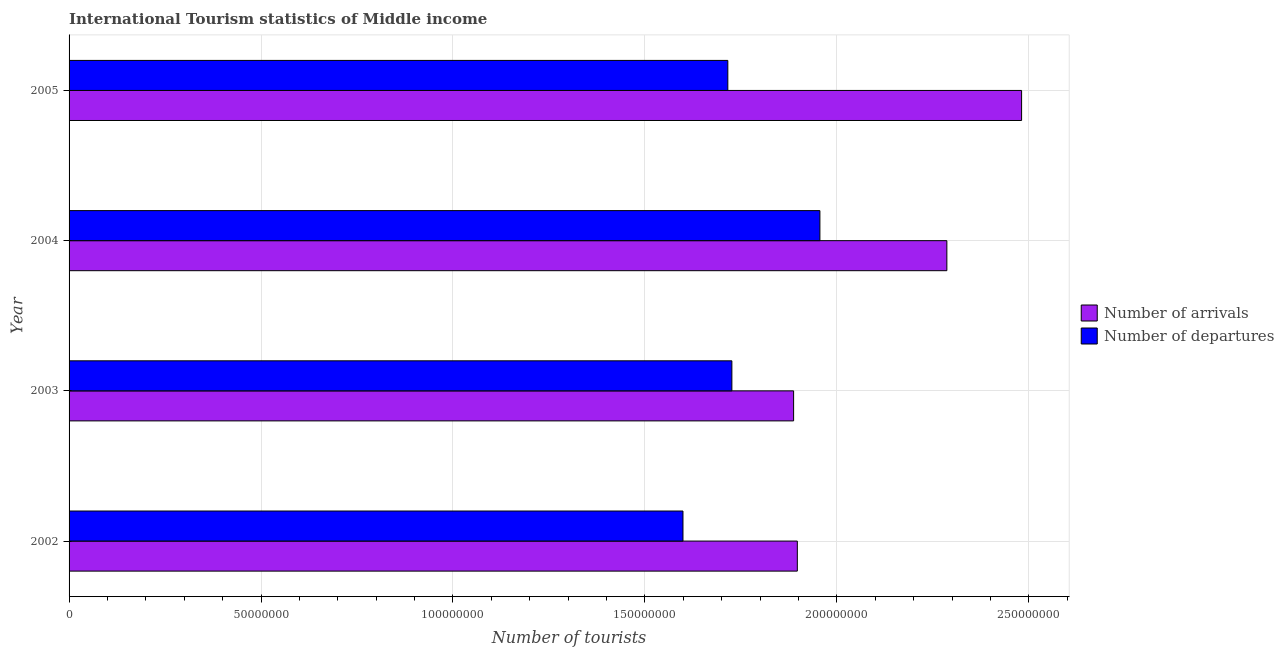How many groups of bars are there?
Keep it short and to the point. 4. Are the number of bars on each tick of the Y-axis equal?
Make the answer very short. Yes. How many bars are there on the 2nd tick from the top?
Keep it short and to the point. 2. What is the label of the 4th group of bars from the top?
Your answer should be compact. 2002. What is the number of tourist arrivals in 2003?
Provide a short and direct response. 1.89e+08. Across all years, what is the maximum number of tourist departures?
Provide a succinct answer. 1.96e+08. Across all years, what is the minimum number of tourist arrivals?
Make the answer very short. 1.89e+08. In which year was the number of tourist departures minimum?
Your answer should be compact. 2002. What is the total number of tourist arrivals in the graph?
Your answer should be compact. 8.55e+08. What is the difference between the number of tourist departures in 2002 and that in 2003?
Offer a very short reply. -1.27e+07. What is the difference between the number of tourist arrivals in 2002 and the number of tourist departures in 2003?
Offer a terse response. 1.70e+07. What is the average number of tourist arrivals per year?
Offer a terse response. 2.14e+08. In the year 2003, what is the difference between the number of tourist departures and number of tourist arrivals?
Offer a terse response. -1.61e+07. What is the ratio of the number of tourist departures in 2002 to that in 2004?
Provide a short and direct response. 0.82. Is the difference between the number of tourist departures in 2002 and 2005 greater than the difference between the number of tourist arrivals in 2002 and 2005?
Ensure brevity in your answer.  Yes. What is the difference between the highest and the second highest number of tourist arrivals?
Your answer should be very brief. 1.95e+07. What is the difference between the highest and the lowest number of tourist arrivals?
Make the answer very short. 5.94e+07. In how many years, is the number of tourist departures greater than the average number of tourist departures taken over all years?
Offer a very short reply. 1. What does the 2nd bar from the top in 2002 represents?
Keep it short and to the point. Number of arrivals. What does the 1st bar from the bottom in 2003 represents?
Make the answer very short. Number of arrivals. How many years are there in the graph?
Give a very brief answer. 4. What is the difference between two consecutive major ticks on the X-axis?
Keep it short and to the point. 5.00e+07. Are the values on the major ticks of X-axis written in scientific E-notation?
Offer a very short reply. No. Does the graph contain any zero values?
Offer a terse response. No. Does the graph contain grids?
Your response must be concise. Yes. How are the legend labels stacked?
Your response must be concise. Vertical. What is the title of the graph?
Provide a succinct answer. International Tourism statistics of Middle income. Does "Frequency of shipment arrival" appear as one of the legend labels in the graph?
Offer a terse response. No. What is the label or title of the X-axis?
Your response must be concise. Number of tourists. What is the label or title of the Y-axis?
Offer a terse response. Year. What is the Number of tourists in Number of arrivals in 2002?
Make the answer very short. 1.90e+08. What is the Number of tourists in Number of departures in 2002?
Give a very brief answer. 1.60e+08. What is the Number of tourists in Number of arrivals in 2003?
Provide a short and direct response. 1.89e+08. What is the Number of tourists in Number of departures in 2003?
Provide a succinct answer. 1.73e+08. What is the Number of tourists of Number of arrivals in 2004?
Your answer should be compact. 2.29e+08. What is the Number of tourists in Number of departures in 2004?
Your answer should be very brief. 1.96e+08. What is the Number of tourists in Number of arrivals in 2005?
Provide a succinct answer. 2.48e+08. What is the Number of tourists in Number of departures in 2005?
Keep it short and to the point. 1.72e+08. Across all years, what is the maximum Number of tourists in Number of arrivals?
Your answer should be compact. 2.48e+08. Across all years, what is the maximum Number of tourists of Number of departures?
Keep it short and to the point. 1.96e+08. Across all years, what is the minimum Number of tourists in Number of arrivals?
Ensure brevity in your answer.  1.89e+08. Across all years, what is the minimum Number of tourists of Number of departures?
Your answer should be compact. 1.60e+08. What is the total Number of tourists in Number of arrivals in the graph?
Provide a short and direct response. 8.55e+08. What is the total Number of tourists in Number of departures in the graph?
Offer a terse response. 7.00e+08. What is the difference between the Number of tourists in Number of arrivals in 2002 and that in 2003?
Give a very brief answer. 9.66e+05. What is the difference between the Number of tourists of Number of departures in 2002 and that in 2003?
Offer a terse response. -1.27e+07. What is the difference between the Number of tourists of Number of arrivals in 2002 and that in 2004?
Your response must be concise. -3.90e+07. What is the difference between the Number of tourists in Number of departures in 2002 and that in 2004?
Offer a terse response. -3.57e+07. What is the difference between the Number of tourists in Number of arrivals in 2002 and that in 2005?
Make the answer very short. -5.84e+07. What is the difference between the Number of tourists in Number of departures in 2002 and that in 2005?
Provide a succinct answer. -1.17e+07. What is the difference between the Number of tourists of Number of arrivals in 2003 and that in 2004?
Your answer should be very brief. -3.99e+07. What is the difference between the Number of tourists of Number of departures in 2003 and that in 2004?
Provide a short and direct response. -2.29e+07. What is the difference between the Number of tourists in Number of arrivals in 2003 and that in 2005?
Offer a very short reply. -5.94e+07. What is the difference between the Number of tourists of Number of departures in 2003 and that in 2005?
Provide a short and direct response. 1.05e+06. What is the difference between the Number of tourists of Number of arrivals in 2004 and that in 2005?
Give a very brief answer. -1.95e+07. What is the difference between the Number of tourists in Number of departures in 2004 and that in 2005?
Make the answer very short. 2.40e+07. What is the difference between the Number of tourists of Number of arrivals in 2002 and the Number of tourists of Number of departures in 2003?
Your response must be concise. 1.70e+07. What is the difference between the Number of tourists of Number of arrivals in 2002 and the Number of tourists of Number of departures in 2004?
Make the answer very short. -5.88e+06. What is the difference between the Number of tourists in Number of arrivals in 2002 and the Number of tourists in Number of departures in 2005?
Your answer should be compact. 1.81e+07. What is the difference between the Number of tourists of Number of arrivals in 2003 and the Number of tourists of Number of departures in 2004?
Your answer should be compact. -6.85e+06. What is the difference between the Number of tourists of Number of arrivals in 2003 and the Number of tourists of Number of departures in 2005?
Provide a short and direct response. 1.71e+07. What is the difference between the Number of tourists of Number of arrivals in 2004 and the Number of tourists of Number of departures in 2005?
Provide a succinct answer. 5.71e+07. What is the average Number of tourists of Number of arrivals per year?
Provide a short and direct response. 2.14e+08. What is the average Number of tourists in Number of departures per year?
Your answer should be very brief. 1.75e+08. In the year 2002, what is the difference between the Number of tourists of Number of arrivals and Number of tourists of Number of departures?
Offer a terse response. 2.98e+07. In the year 2003, what is the difference between the Number of tourists of Number of arrivals and Number of tourists of Number of departures?
Give a very brief answer. 1.61e+07. In the year 2004, what is the difference between the Number of tourists of Number of arrivals and Number of tourists of Number of departures?
Offer a very short reply. 3.31e+07. In the year 2005, what is the difference between the Number of tourists of Number of arrivals and Number of tourists of Number of departures?
Offer a very short reply. 7.65e+07. What is the ratio of the Number of tourists in Number of arrivals in 2002 to that in 2003?
Provide a succinct answer. 1.01. What is the ratio of the Number of tourists of Number of departures in 2002 to that in 2003?
Keep it short and to the point. 0.93. What is the ratio of the Number of tourists of Number of arrivals in 2002 to that in 2004?
Keep it short and to the point. 0.83. What is the ratio of the Number of tourists of Number of departures in 2002 to that in 2004?
Offer a terse response. 0.82. What is the ratio of the Number of tourists in Number of arrivals in 2002 to that in 2005?
Provide a succinct answer. 0.76. What is the ratio of the Number of tourists of Number of departures in 2002 to that in 2005?
Your response must be concise. 0.93. What is the ratio of the Number of tourists in Number of arrivals in 2003 to that in 2004?
Offer a terse response. 0.83. What is the ratio of the Number of tourists of Number of departures in 2003 to that in 2004?
Your response must be concise. 0.88. What is the ratio of the Number of tourists in Number of arrivals in 2003 to that in 2005?
Your answer should be very brief. 0.76. What is the ratio of the Number of tourists in Number of departures in 2003 to that in 2005?
Your answer should be compact. 1.01. What is the ratio of the Number of tourists of Number of arrivals in 2004 to that in 2005?
Your response must be concise. 0.92. What is the ratio of the Number of tourists of Number of departures in 2004 to that in 2005?
Offer a terse response. 1.14. What is the difference between the highest and the second highest Number of tourists of Number of arrivals?
Your answer should be compact. 1.95e+07. What is the difference between the highest and the second highest Number of tourists in Number of departures?
Provide a short and direct response. 2.29e+07. What is the difference between the highest and the lowest Number of tourists in Number of arrivals?
Give a very brief answer. 5.94e+07. What is the difference between the highest and the lowest Number of tourists in Number of departures?
Keep it short and to the point. 3.57e+07. 